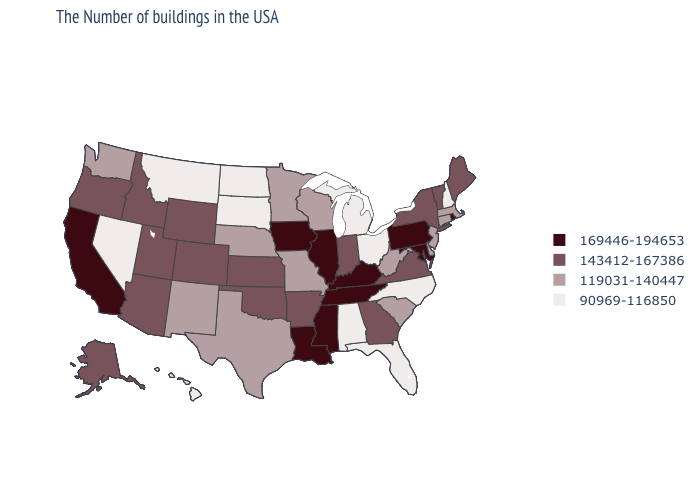Which states have the lowest value in the MidWest?
Be succinct. Ohio, Michigan, South Dakota, North Dakota. Which states have the highest value in the USA?
Keep it brief. Rhode Island, Maryland, Pennsylvania, Kentucky, Tennessee, Illinois, Mississippi, Louisiana, Iowa, California. What is the highest value in the USA?
Keep it brief. 169446-194653. What is the highest value in states that border Louisiana?
Give a very brief answer. 169446-194653. Among the states that border New Hampshire , does Vermont have the highest value?
Quick response, please. Yes. Does California have the highest value in the West?
Keep it brief. Yes. Does Minnesota have the highest value in the MidWest?
Keep it brief. No. Among the states that border Idaho , which have the highest value?
Short answer required. Wyoming, Utah, Oregon. What is the highest value in states that border Mississippi?
Keep it brief. 169446-194653. Name the states that have a value in the range 169446-194653?
Write a very short answer. Rhode Island, Maryland, Pennsylvania, Kentucky, Tennessee, Illinois, Mississippi, Louisiana, Iowa, California. What is the value of Indiana?
Keep it brief. 143412-167386. Name the states that have a value in the range 143412-167386?
Answer briefly. Maine, Vermont, New York, Virginia, Georgia, Indiana, Arkansas, Kansas, Oklahoma, Wyoming, Colorado, Utah, Arizona, Idaho, Oregon, Alaska. Does New Jersey have the lowest value in the USA?
Keep it brief. No. Which states have the lowest value in the Northeast?
Give a very brief answer. New Hampshire. 